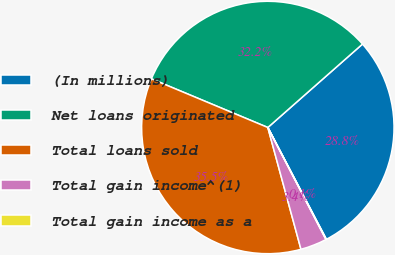<chart> <loc_0><loc_0><loc_500><loc_500><pie_chart><fcel>(In millions)<fcel>Net loans originated<fcel>Total loans sold<fcel>Total gain income^(1)<fcel>Total gain income as a<nl><fcel>28.82%<fcel>32.2%<fcel>35.53%<fcel>3.39%<fcel>0.06%<nl></chart> 